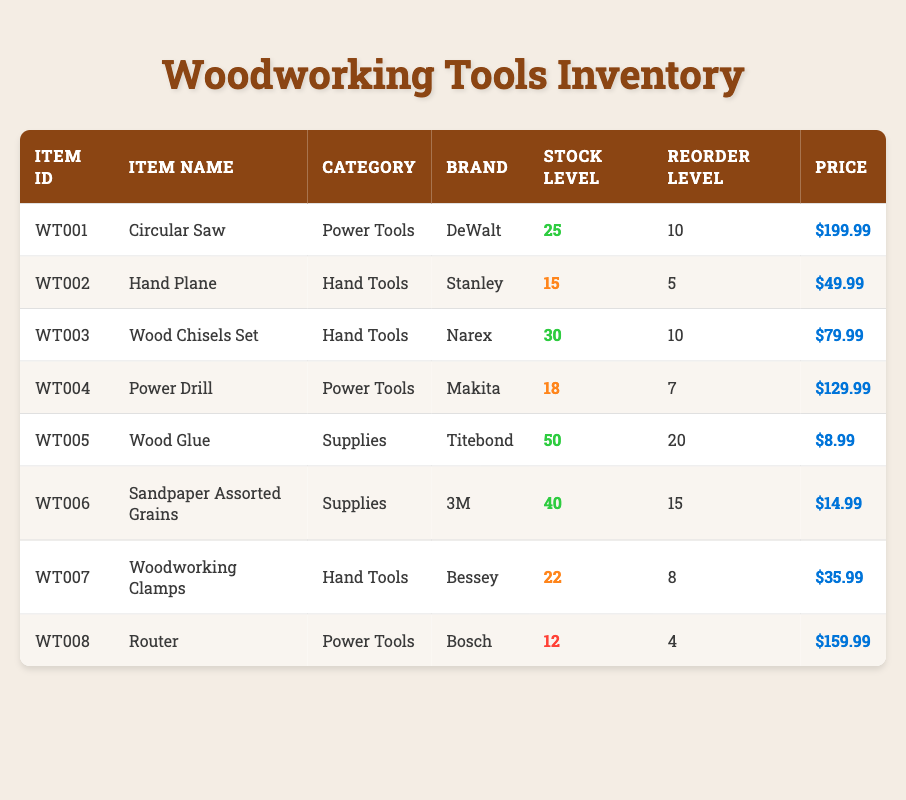What is the stock level of the Circular Saw? The stock level is found in the "Stock Level" column corresponding to the row for the Circular Saw. The value listed there is 25.
Answer: 25 Is the stock level of the Router below the reorder level? The stock level for the Router is 12 and its reorder level is 4. Since 12 is greater than 4, the stock level is not below the reorder level.
Answer: No Which item has the highest stock level? To find the highest stock level, compare the values in the "Stock Level" column. The highest value is 50, which corresponds to the Wood Glue.
Answer: Wood Glue Calculate the average price of Hand Tools in the inventory. The Hand Tools are the Hand Plane, Wood Chisels Set, and Woodworking Clamps with respective prices of 49.99, 79.99, and 35.99. The total price is 49.99 + 79.99 + 35.99 = 165.97. The average price is 165.97 / 3 = 55.32.
Answer: 55.32 Are there more than 20 units of any supplies in stock? The Supplies category items are Wood Glue (50) and Sandpaper Assorted Grains (40). Both have stock levels over 20, fulfilling the condition.
Answer: Yes What is the reorder level of the Power Drill? The reorder level is listed in the "Reorder Level" column for the Power Drill. The value there is 7.
Answer: 7 Which brand has the least stock level in this inventory? The item with the least stock level is the Router, with a stock level of 12. By reviewing the rows, it is clear that this is the minimum stock level among all brands.
Answer: Bosch How many total power tools are in stock? The Power Tools listed are the Circular Saw (25), Power Drill (18), and Router (12). Sum these values: 25 + 18 + 12 = 55.
Answer: 55 What is the combined stock level of all Hand Tools? The Hand Tools are the Hand Plane (15), Wood Chisels Set (30), and Woodworking Clamps (22). The combined stock level can be calculated by summing these values: 15 + 30 + 22 = 67.
Answer: 67 